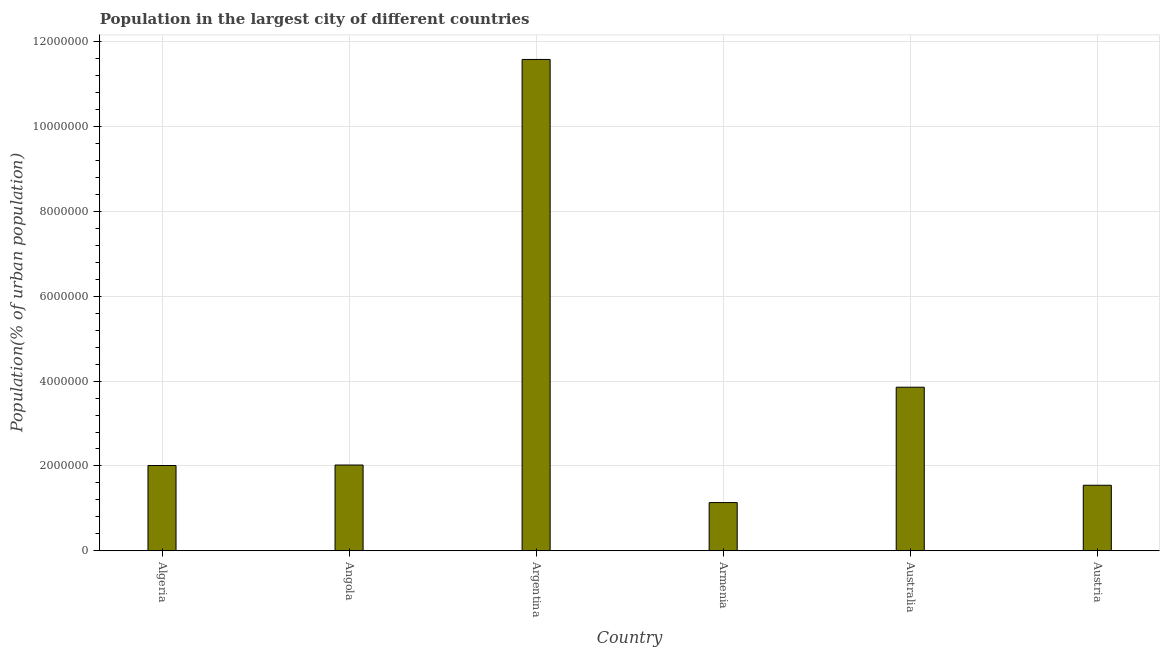What is the title of the graph?
Give a very brief answer. Population in the largest city of different countries. What is the label or title of the Y-axis?
Your answer should be compact. Population(% of urban population). What is the population in largest city in Armenia?
Offer a very short reply. 1.14e+06. Across all countries, what is the maximum population in largest city?
Provide a succinct answer. 1.16e+07. Across all countries, what is the minimum population in largest city?
Give a very brief answer. 1.14e+06. In which country was the population in largest city minimum?
Your answer should be very brief. Armenia. What is the sum of the population in largest city?
Offer a terse response. 2.22e+07. What is the difference between the population in largest city in Algeria and Austria?
Your response must be concise. 4.65e+05. What is the average population in largest city per country?
Provide a succinct answer. 3.69e+06. What is the median population in largest city?
Ensure brevity in your answer.  2.02e+06. What is the ratio of the population in largest city in Algeria to that in Australia?
Make the answer very short. 0.52. What is the difference between the highest and the second highest population in largest city?
Keep it short and to the point. 7.73e+06. Is the sum of the population in largest city in Armenia and Austria greater than the maximum population in largest city across all countries?
Your response must be concise. No. What is the difference between the highest and the lowest population in largest city?
Ensure brevity in your answer.  1.05e+07. In how many countries, is the population in largest city greater than the average population in largest city taken over all countries?
Keep it short and to the point. 2. Are all the bars in the graph horizontal?
Give a very brief answer. No. What is the difference between two consecutive major ticks on the Y-axis?
Keep it short and to the point. 2.00e+06. Are the values on the major ticks of Y-axis written in scientific E-notation?
Provide a succinct answer. No. What is the Population(% of urban population) of Algeria?
Provide a short and direct response. 2.01e+06. What is the Population(% of urban population) of Angola?
Ensure brevity in your answer.  2.02e+06. What is the Population(% of urban population) in Argentina?
Offer a terse response. 1.16e+07. What is the Population(% of urban population) of Armenia?
Ensure brevity in your answer.  1.14e+06. What is the Population(% of urban population) in Australia?
Offer a terse response. 3.86e+06. What is the Population(% of urban population) in Austria?
Your answer should be compact. 1.55e+06. What is the difference between the Population(% of urban population) in Algeria and Angola?
Offer a very short reply. -1.17e+04. What is the difference between the Population(% of urban population) in Algeria and Argentina?
Offer a very short reply. -9.58e+06. What is the difference between the Population(% of urban population) in Algeria and Armenia?
Give a very brief answer. 8.74e+05. What is the difference between the Population(% of urban population) in Algeria and Australia?
Give a very brief answer. -1.85e+06. What is the difference between the Population(% of urban population) in Algeria and Austria?
Offer a terse response. 4.65e+05. What is the difference between the Population(% of urban population) in Angola and Argentina?
Keep it short and to the point. -9.56e+06. What is the difference between the Population(% of urban population) in Angola and Armenia?
Keep it short and to the point. 8.86e+05. What is the difference between the Population(% of urban population) in Angola and Australia?
Provide a short and direct response. -1.83e+06. What is the difference between the Population(% of urban population) in Angola and Austria?
Make the answer very short. 4.77e+05. What is the difference between the Population(% of urban population) in Argentina and Armenia?
Your answer should be very brief. 1.05e+07. What is the difference between the Population(% of urban population) in Argentina and Australia?
Your answer should be very brief. 7.73e+06. What is the difference between the Population(% of urban population) in Argentina and Austria?
Offer a terse response. 1.00e+07. What is the difference between the Population(% of urban population) in Armenia and Australia?
Give a very brief answer. -2.72e+06. What is the difference between the Population(% of urban population) in Armenia and Austria?
Provide a succinct answer. -4.09e+05. What is the difference between the Population(% of urban population) in Australia and Austria?
Offer a very short reply. 2.31e+06. What is the ratio of the Population(% of urban population) in Algeria to that in Angola?
Give a very brief answer. 0.99. What is the ratio of the Population(% of urban population) in Algeria to that in Argentina?
Ensure brevity in your answer.  0.17. What is the ratio of the Population(% of urban population) in Algeria to that in Armenia?
Provide a short and direct response. 1.77. What is the ratio of the Population(% of urban population) in Algeria to that in Australia?
Your response must be concise. 0.52. What is the ratio of the Population(% of urban population) in Algeria to that in Austria?
Offer a terse response. 1.3. What is the ratio of the Population(% of urban population) in Angola to that in Argentina?
Ensure brevity in your answer.  0.17. What is the ratio of the Population(% of urban population) in Angola to that in Armenia?
Provide a succinct answer. 1.78. What is the ratio of the Population(% of urban population) in Angola to that in Australia?
Offer a very short reply. 0.52. What is the ratio of the Population(% of urban population) in Angola to that in Austria?
Your answer should be very brief. 1.31. What is the ratio of the Population(% of urban population) in Argentina to that in Armenia?
Your answer should be very brief. 10.2. What is the ratio of the Population(% of urban population) in Argentina to that in Australia?
Keep it short and to the point. 3. What is the ratio of the Population(% of urban population) in Argentina to that in Austria?
Your response must be concise. 7.5. What is the ratio of the Population(% of urban population) in Armenia to that in Australia?
Provide a short and direct response. 0.29. What is the ratio of the Population(% of urban population) in Armenia to that in Austria?
Your answer should be compact. 0.73. What is the ratio of the Population(% of urban population) in Australia to that in Austria?
Your answer should be very brief. 2.5. 